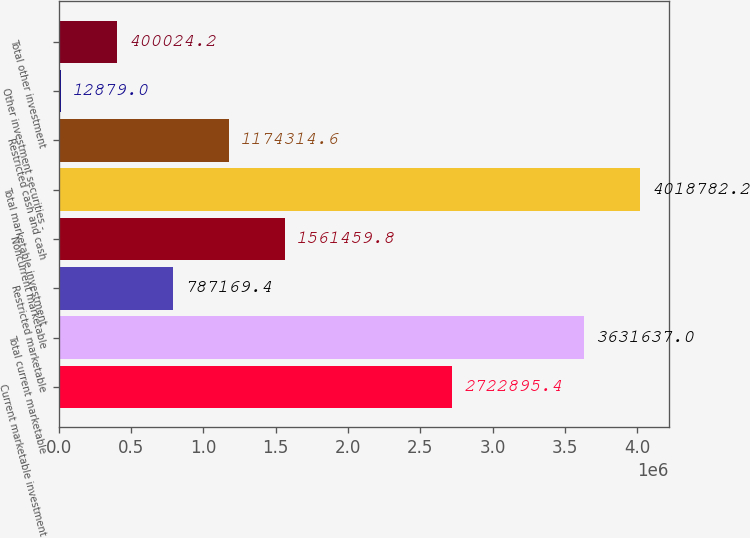Convert chart to OTSL. <chart><loc_0><loc_0><loc_500><loc_500><bar_chart><fcel>Current marketable investment<fcel>Total current marketable<fcel>Restricted marketable<fcel>Noncurrent marketable<fcel>Total marketable investment<fcel>Restricted cash and cash<fcel>Other investment securities -<fcel>Total other investment<nl><fcel>2.7229e+06<fcel>3.63164e+06<fcel>787169<fcel>1.56146e+06<fcel>4.01878e+06<fcel>1.17431e+06<fcel>12879<fcel>400024<nl></chart> 